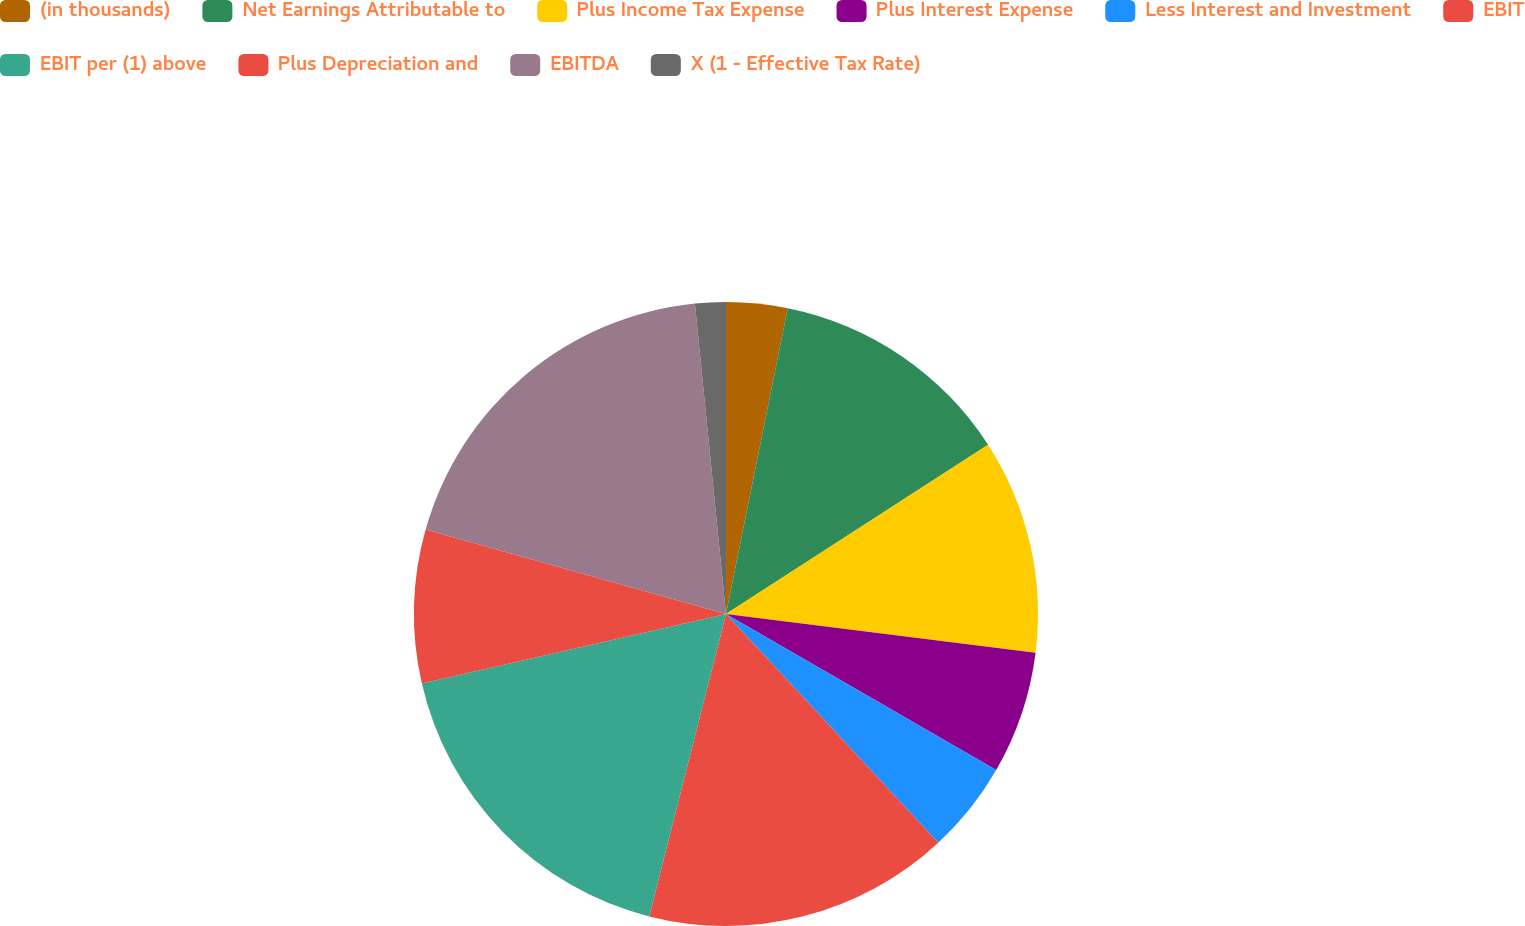<chart> <loc_0><loc_0><loc_500><loc_500><pie_chart><fcel>(in thousands)<fcel>Net Earnings Attributable to<fcel>Plus Income Tax Expense<fcel>Plus Interest Expense<fcel>Less Interest and Investment<fcel>EBIT<fcel>EBIT per (1) above<fcel>Plus Depreciation and<fcel>EBITDA<fcel>X (1 - Effective Tax Rate)<nl><fcel>3.17%<fcel>12.7%<fcel>11.11%<fcel>6.35%<fcel>4.76%<fcel>15.87%<fcel>17.46%<fcel>7.94%<fcel>19.05%<fcel>1.59%<nl></chart> 